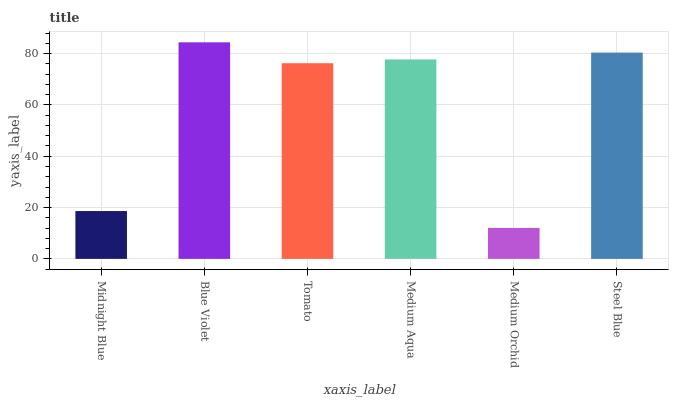Is Medium Orchid the minimum?
Answer yes or no. Yes. Is Blue Violet the maximum?
Answer yes or no. Yes. Is Tomato the minimum?
Answer yes or no. No. Is Tomato the maximum?
Answer yes or no. No. Is Blue Violet greater than Tomato?
Answer yes or no. Yes. Is Tomato less than Blue Violet?
Answer yes or no. Yes. Is Tomato greater than Blue Violet?
Answer yes or no. No. Is Blue Violet less than Tomato?
Answer yes or no. No. Is Medium Aqua the high median?
Answer yes or no. Yes. Is Tomato the low median?
Answer yes or no. Yes. Is Medium Orchid the high median?
Answer yes or no. No. Is Medium Aqua the low median?
Answer yes or no. No. 